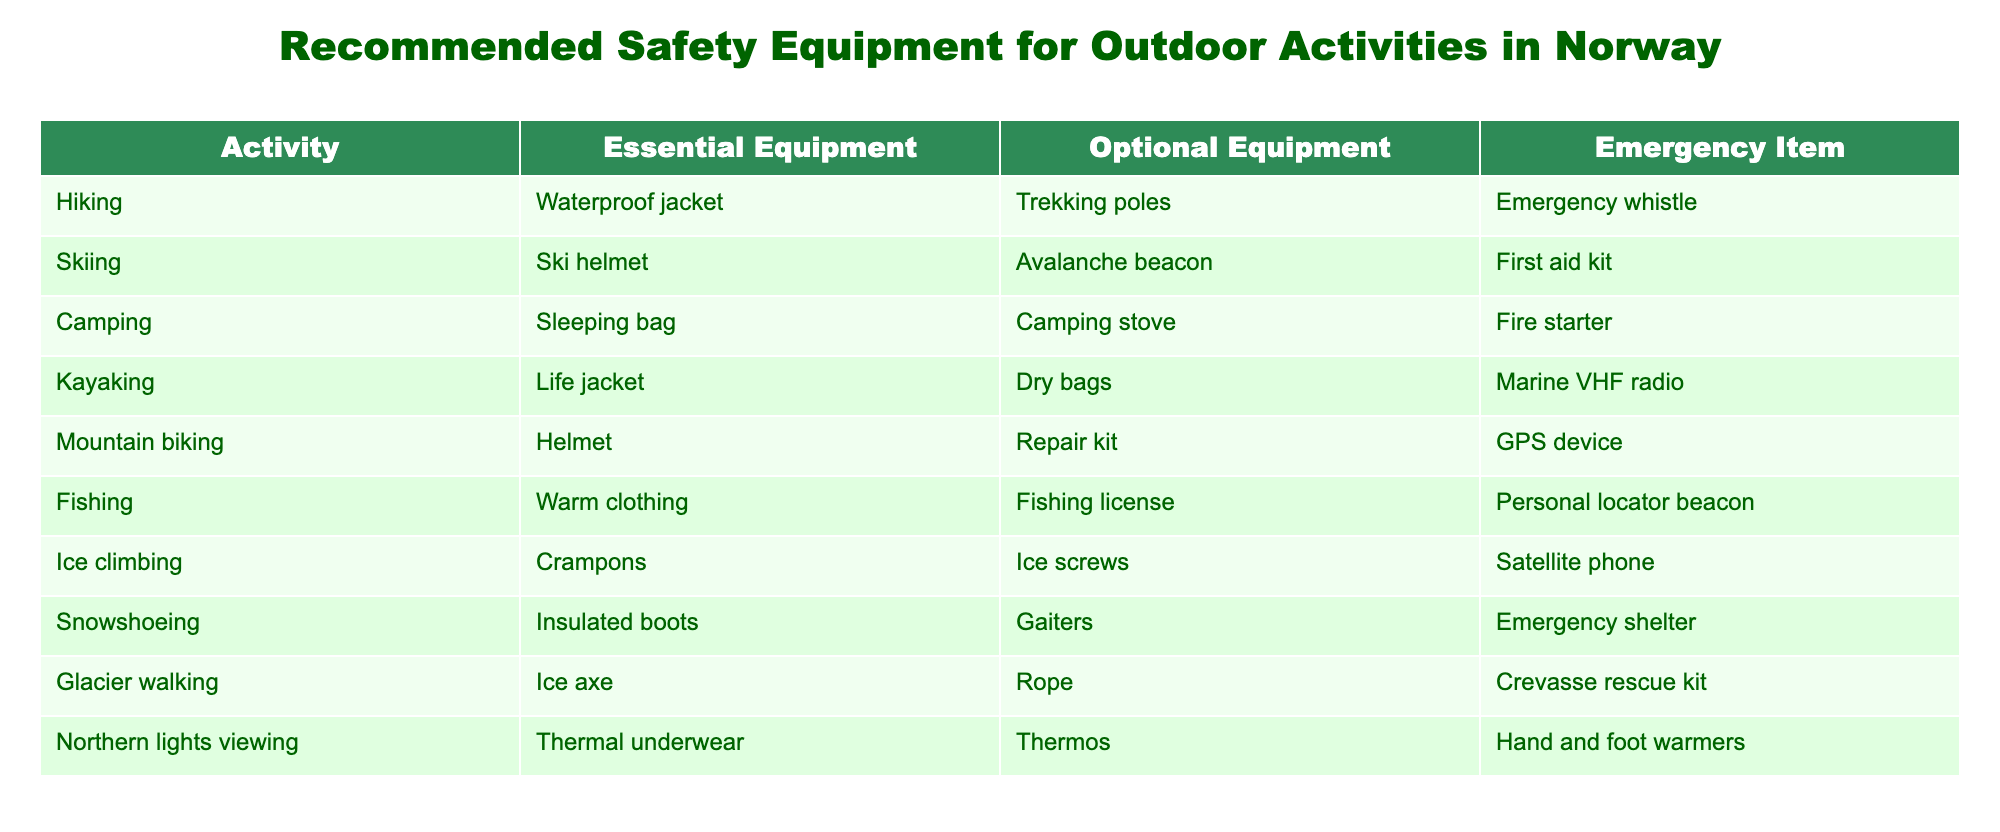What essential equipment is recommended for hiking? In the table, the row corresponding to hiking shows "Waterproof jacket" listed under Essential Equipment. Therefore, the essential equipment recommended for hiking is a waterproof jacket.
Answer: Waterproof jacket Which activity recommends using a life jacket? Looking at the table, under the activity column, the entry for kayaking includes "Life jacket" in the Essential Equipment section. This indicates that kayaking recommends using a life jacket.
Answer: Kayaking How many types of optional equipment are listed across all activities? By counting the optional equipment from each activity in the table, we can see they are: Trekking poles, Avalanche beacon, Camping stove, Dry bags, Repair kit, Fishing license, Ice screws, Gaiters, Rope, Thermos. Thus, there are 10 types of optional equipment listed.
Answer: 10 Is a first aid kit listed as an emergency item for fishing? In the table, the entry for fishing does not include a first aid kit in the Emergency Item column; instead, it lists a Personal locator beacon. Therefore, the answer to this question is no.
Answer: No Which activity requires the most items from the essential equipment, optional equipment, and emergency item categories combined? By inspecting the table for each activity, we see that hiking has 3 items (Waterproof jacket, Trekking poles, Emergency whistle), skiing has 3 (Ski helmet, Avalanche beacon, First aid kit), camping has 3 (Sleeping bag, Camping stove, Fire starter), kayaking has 3 (Life jacket, Dry bags, Marine VHF radio), etc. Each activity has a total of 3 items combined, meaning they are all equal in item counts.
Answer: No activity requires more than 3 items What is the relationship between snowshoeing's optional equipment and its emergency item? For snowshoeing, the optional equipment is "Gaiters" and the emergency item is "Emergency shelter." There is no direct relationship in the table that indicates one is a prerequisite for the other, but both items serve different purposes in ensuring safety and comfort during the activity.
Answer: No direct relationship Which activities are suggested to have both an insulation item for warmth and a first aid kit for emergencies? Upon examination of the table, it shows that skiing has a first aid kit, but the focus on warmth appears in fishing with "Warm clothing." So no activity has both items listed.
Answer: No activities Does glacier walking use an ice axe as an essential piece of equipment? Referring to the table, the entry under glacier walking confirms that "Ice axe" is listed in the Essential Equipment column. Thus, an ice axe is indeed essential for glacier walking.
Answer: Yes 